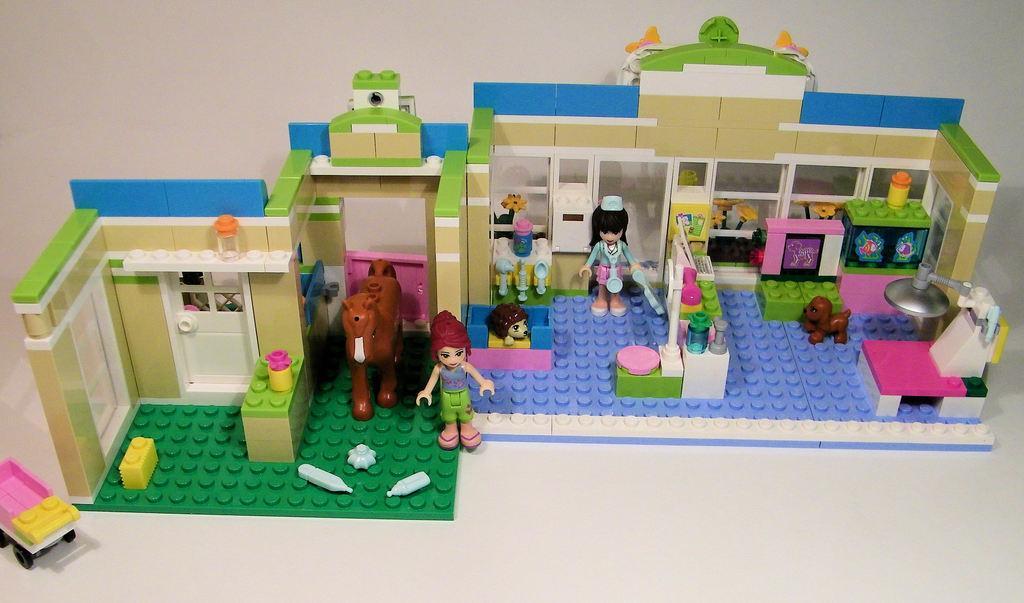How would you summarize this image in a sentence or two? In this image I can see a toy house, person, animals, table and other objects may be kept on the floor. This image is taken may be in a hall. 